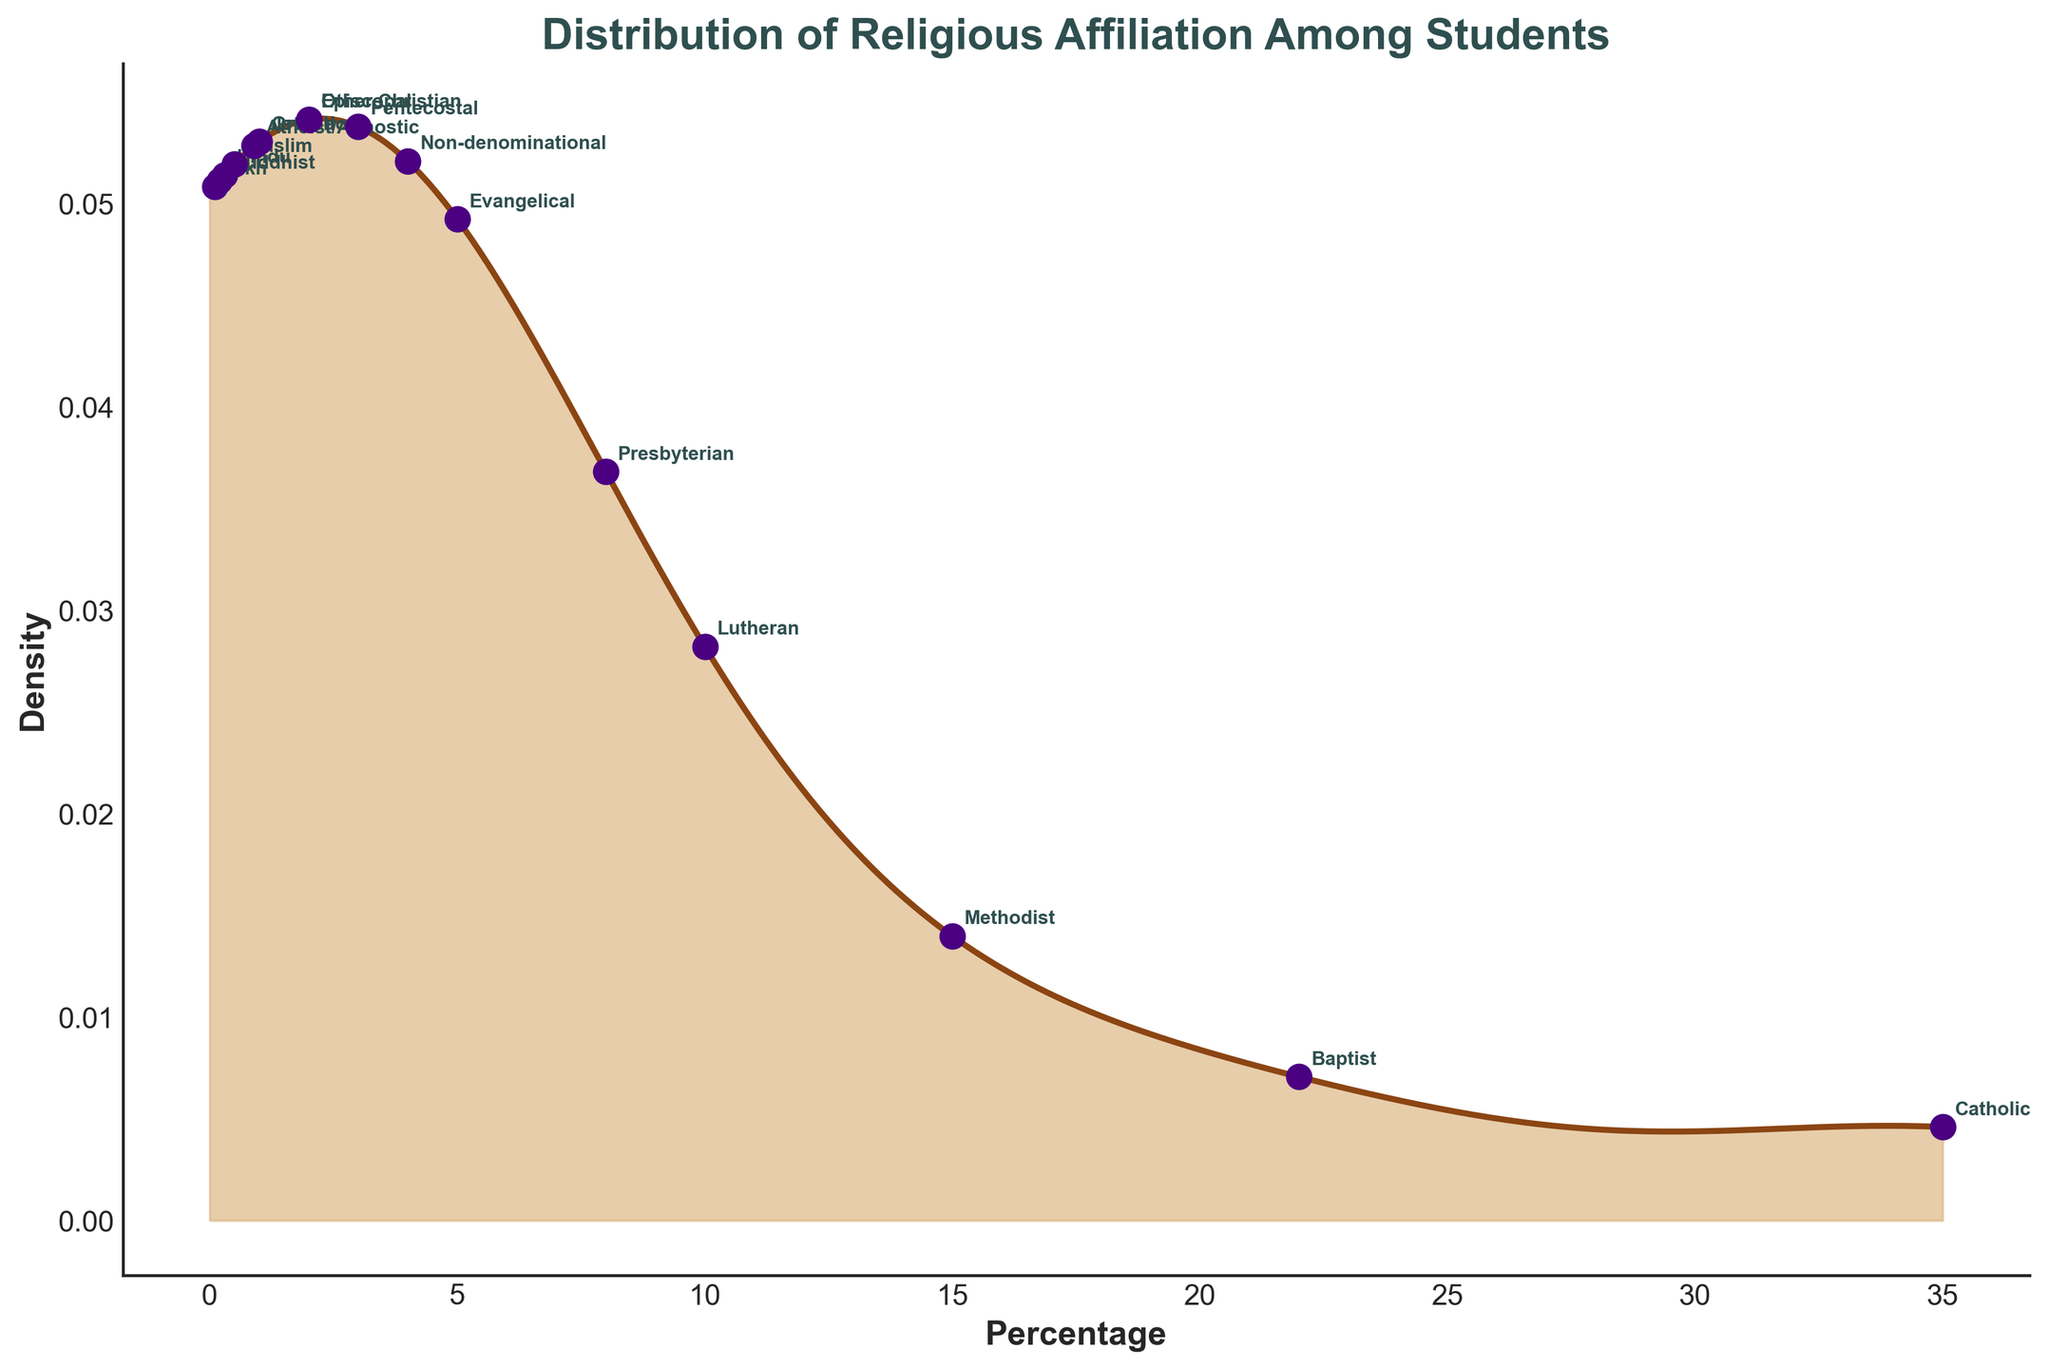What is the title of the figure? The title is written at the top of the figure and summarizes the main subject of the plot.
Answer: Distribution of Religious Affiliation Among Students Which denomination has the highest percentage among students? The denomination with the highest density value on the x-axis represents the denomination with the highest percentage.
Answer: Catholic What is the approximate percentage of Presbyterian students? Look for the annotation near the label 'Presbyterian' on the x-axis to identify its percentage.
Answer: 8% How many denominations have a percentage of less than 2%? Identify the denominations with percentage values less than 2% from the scatter points on the x-axis and count them.
Answer: 6 Which denomination has a lower percentage: Hindu or Jewish? Compare the percentages annotated for 'Hindu' and 'Jewish' on the x-axis.
Answer: Hindu What is the sum of the percentages of Baptist and Methodist students? Add the percentages of Baptist (22%) and Methodist (15%) students.
Answer: 37% What is the total percentage of students affiliated with 'Other Christian' denominations? Add the percentages of Non-denominational (4%) and Other Christian (2%) students.
Answer: 6% Which denomination has a higher density at its percentage value: Lutheran or Atheist/Agnostic? Compare the height of the density curve at the percentage points for Lutheran (10%) and Atheist/Agnostic (0.9%).
Answer: Lutheran Where is the peak of the density curve located? Identify the x-axis percentage value where the density curve reaches its maximum height.
Answer: Catholic (around 35%) What can you infer about the diversity of religious affiliation among students from the density plot? By observing the spread and concentration of denominations on the density curve, one can infer the diversity and distribution of religious affiliations. A wider spread indicates more diversity.
Answer: The plot indicates a diverse distribution with a significant percentage affiliated with Catholicism but also a wide range of other denominations present 